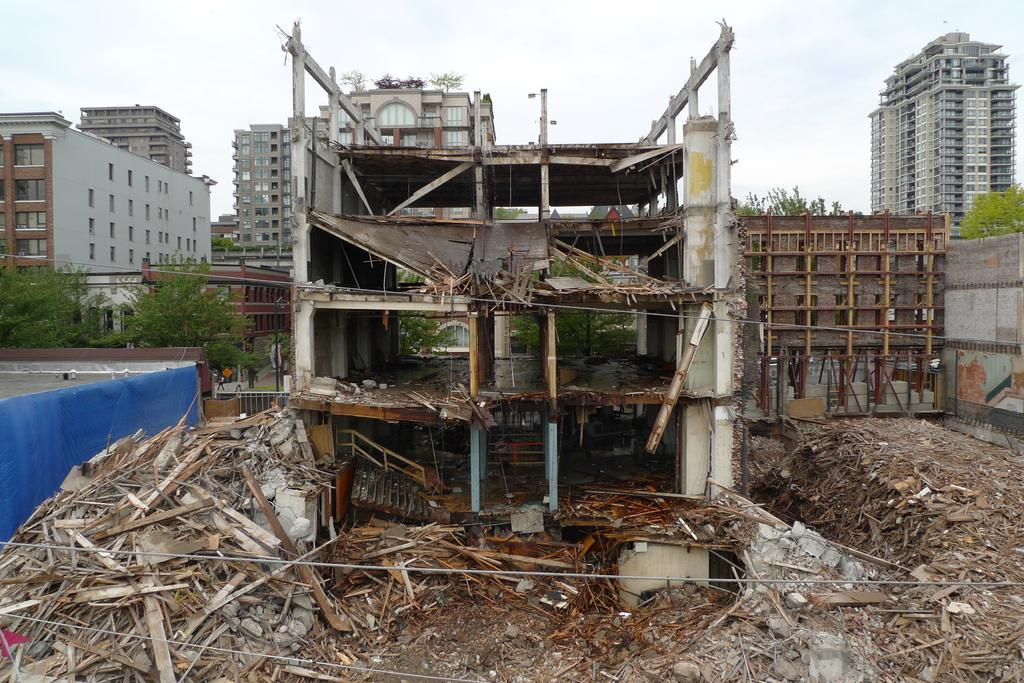What can be seen in the image that is related to infrastructure? There are wires and a construction building in the image. What is visible in the background of the image? There are trees, buildings, and the sky visible in the background of the image. How many crows are sitting on the construction building in the image? There are no crows present in the image. What type of earth can be seen in the image? The image does not show any specific type of earth; it primarily features wires, a construction building, and the background elements. 